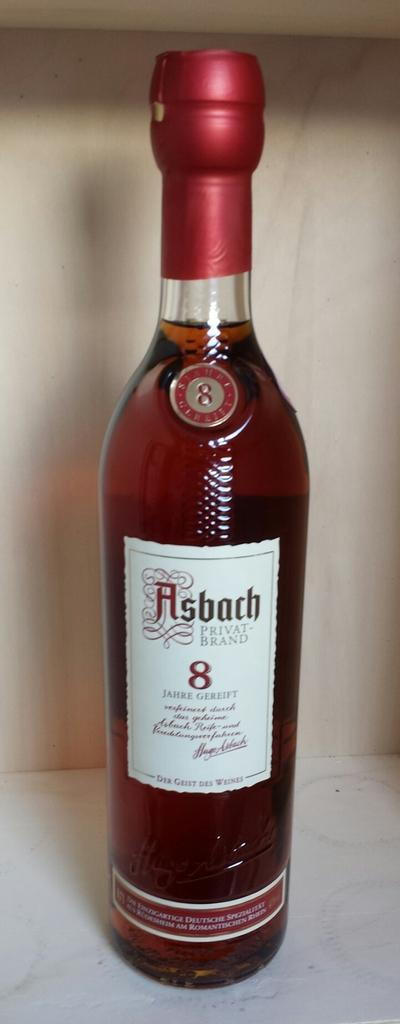<image>
Write a terse but informative summary of the picture. A bottle of Asbach Privat Brand stand on a wooden shelf. 